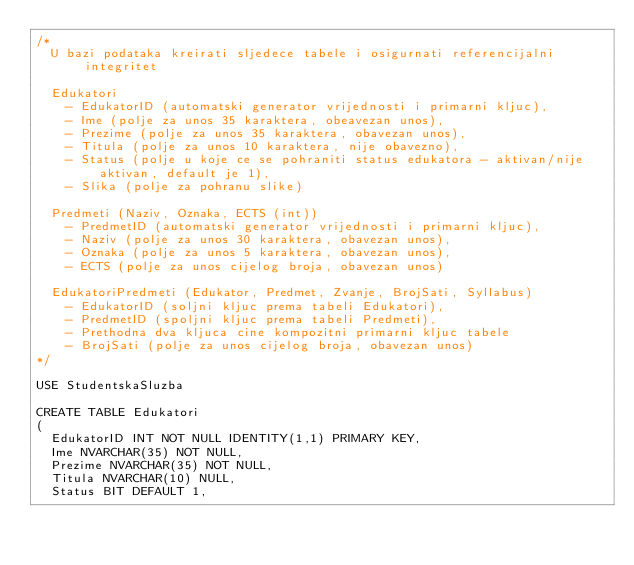<code> <loc_0><loc_0><loc_500><loc_500><_SQL_>/*
	U bazi podataka kreirati sljedece tabele i osigurnati referencijalni integritet

	Edukatori
		- EdukatorID (automatski generator vrijednosti i primarni kljuc),
		- Ime (polje za unos 35 karaktera, obeavezan unos),
		- Prezime (polje za unos 35 karaktera, obavezan unos),
		- Titula (polje za unos 10 karaktera, nije obavezno),
		- Status (polje u koje ce se pohraniti status edukatora - aktivan/nije aktivan, default je 1),
		- Slika (polje za pohranu slike)

	Predmeti (Naziv, Oznaka, ECTS (int))
		- PredmetID (automatski generator vrijednosti i primarni kljuc),
		- Naziv (polje za unos 30 karaktera, obavezan unos),
		- Oznaka (polje za unos 5 karaktera, obavezan unos),
		- ECTS (polje za unos cijelog broja, obavezan unos)

	EdukatoriPredmeti (Edukator, Predmet, Zvanje, BrojSati, Syllabus)
		- EdukatorID (soljni kljuc prema tabeli Edukatori),
		- PredmetID (spoljni kljuc prema tabeli Predmeti),
		- Prethodna dva kljuca cine kompozitni primarni kljuc tabele
		- BrojSati (polje za unos cijelog broja, obavezan unos)
*/

USE StudentskaSluzba

CREATE TABLE Edukatori
(
	EdukatorID INT NOT NULL IDENTITY(1,1) PRIMARY KEY,
	Ime NVARCHAR(35) NOT NULL,
	Prezime NVARCHAR(35) NOT NULL,
	Titula NVARCHAR(10) NULL,
	Status BIT DEFAULT 1,</code> 